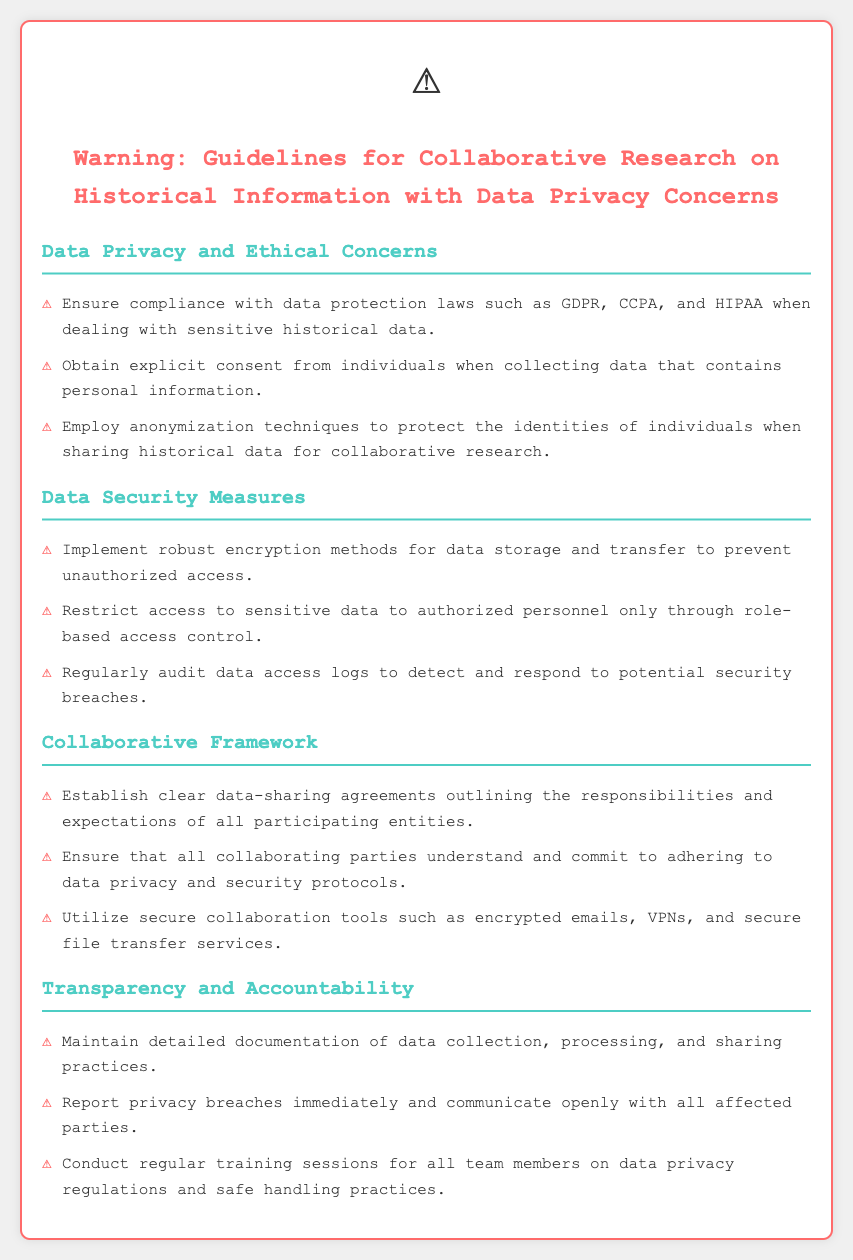What is the document title? The title appears prominently at the top of the document, summarizing the content's focus.
Answer: Warning: Guidelines for Collaborative Research on Historical Information with Data Privacy Concerns Which data protection laws are mentioned? The laws are listed in the section discussing data privacy and ethical concerns, specifically named as GDPR, CCPA, and HIPAA.
Answer: GDPR, CCPA, HIPAA What must be obtained from individuals when collecting personal data? The document states the need for specific action regarding personal data collection.
Answer: Explicit consent What security method is recommended for data storage? The appropriate measure for data security is mentioned directly under the data security measures section.
Answer: Robust encryption methods What is necessary for all participating entities in a collaborative framework? The document emphasizes the importance of specific agreements in collaborative research.
Answer: Clear data-sharing agreements What should be maintained for data practices? A critical aspect of transparency and accountability is documented, specifying what needs to be detailed.
Answer: Documentation How should privacy breaches be handled? The response required in the event of a privacy breach is outlined in the transparency section.
Answer: Report immediately What should be conducted regularly for team members? A specific type of session aimed at improving knowledge and safety practices is highlighted in the accountability section.
Answer: Training sessions 